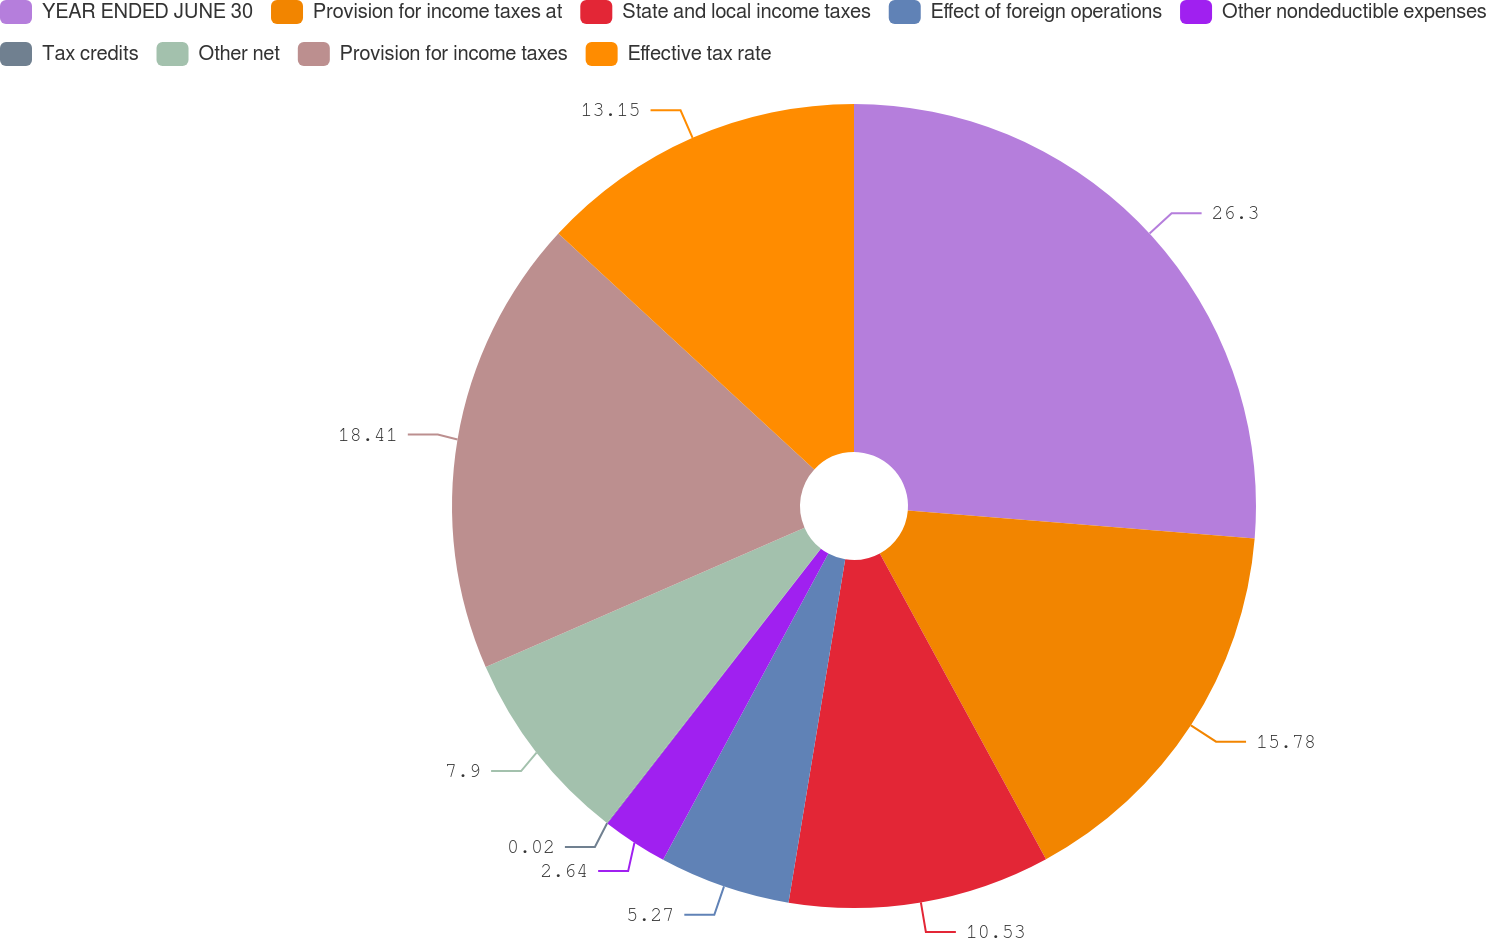Convert chart. <chart><loc_0><loc_0><loc_500><loc_500><pie_chart><fcel>YEAR ENDED JUNE 30<fcel>Provision for income taxes at<fcel>State and local income taxes<fcel>Effect of foreign operations<fcel>Other nondeductible expenses<fcel>Tax credits<fcel>Other net<fcel>Provision for income taxes<fcel>Effective tax rate<nl><fcel>26.29%<fcel>15.78%<fcel>10.53%<fcel>5.27%<fcel>2.64%<fcel>0.02%<fcel>7.9%<fcel>18.41%<fcel>13.15%<nl></chart> 